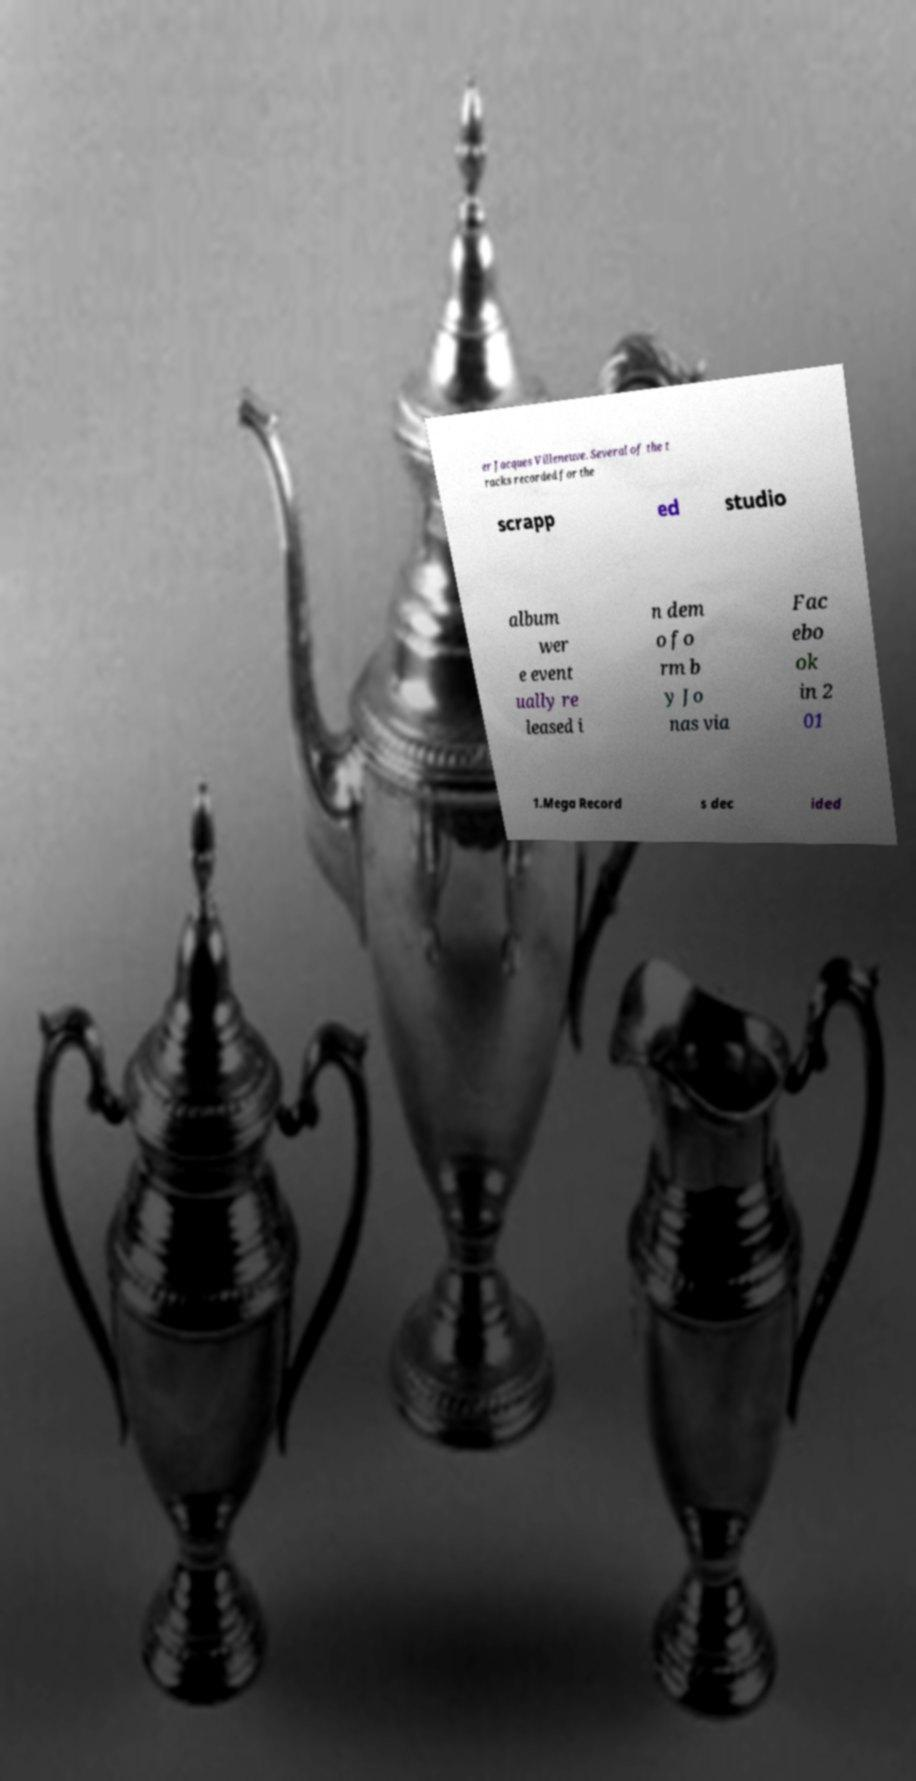What messages or text are displayed in this image? I need them in a readable, typed format. er Jacques Villeneuve. Several of the t racks recorded for the scrapp ed studio album wer e event ually re leased i n dem o fo rm b y Jo nas via Fac ebo ok in 2 01 1.Mega Record s dec ided 